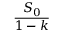Convert formula to latex. <formula><loc_0><loc_0><loc_500><loc_500>\frac { S _ { 0 } } { 1 - k }</formula> 